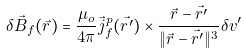<formula> <loc_0><loc_0><loc_500><loc_500>\delta \vec { B } _ { f } ( \vec { r } ) = \frac { \mu _ { o } } { 4 \pi } \vec { j } _ { f } ^ { p } ( \vec { r ^ { \prime } } ) \times \frac { \vec { r } - \vec { r ^ { \prime } } } { \| \vec { r } - \vec { r ^ { \prime } } \| ^ { 3 } } \delta v ^ { \prime }</formula> 